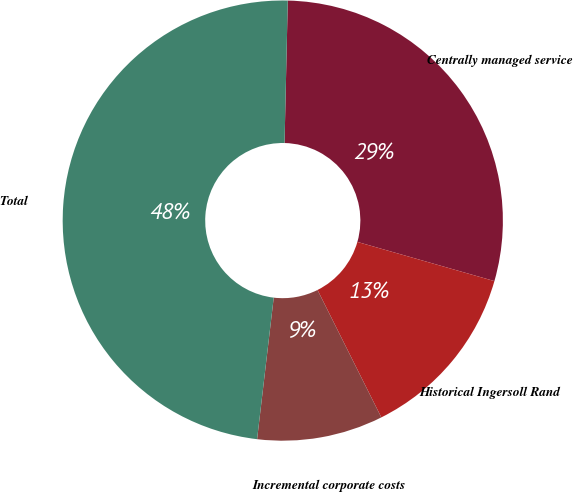<chart> <loc_0><loc_0><loc_500><loc_500><pie_chart><fcel>Centrally managed service<fcel>Historical Ingersoll Rand<fcel>Incremental corporate costs<fcel>Total<nl><fcel>29.07%<fcel>13.18%<fcel>9.25%<fcel>48.5%<nl></chart> 